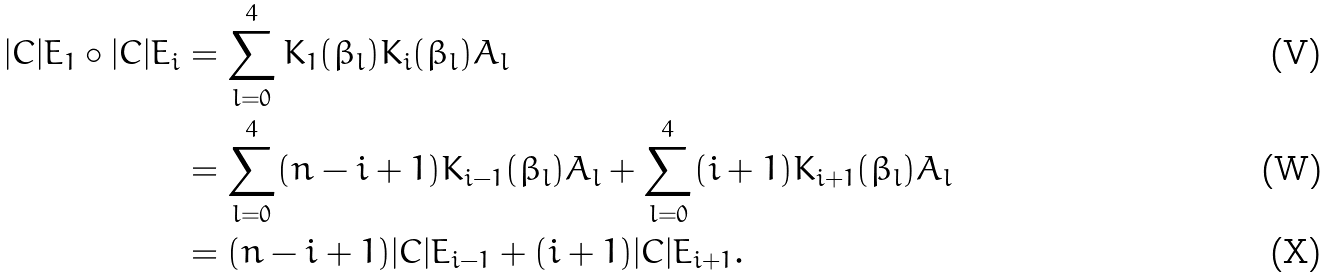Convert formula to latex. <formula><loc_0><loc_0><loc_500><loc_500>| C | E _ { 1 } \circ | C | E _ { i } & = \sum _ { l = 0 } ^ { 4 } K _ { 1 } ( \beta _ { l } ) K _ { i } ( \beta _ { l } ) A _ { l } \\ & = \sum _ { l = 0 } ^ { 4 } ( n - i + 1 ) K _ { i - 1 } ( \beta _ { l } ) A _ { l } + \sum _ { l = 0 } ^ { 4 } ( i + 1 ) K _ { i + 1 } ( \beta _ { l } ) A _ { l } \\ & = ( n - i + 1 ) | C | E _ { i - 1 } + ( i + 1 ) | C | E _ { i + 1 } .</formula> 